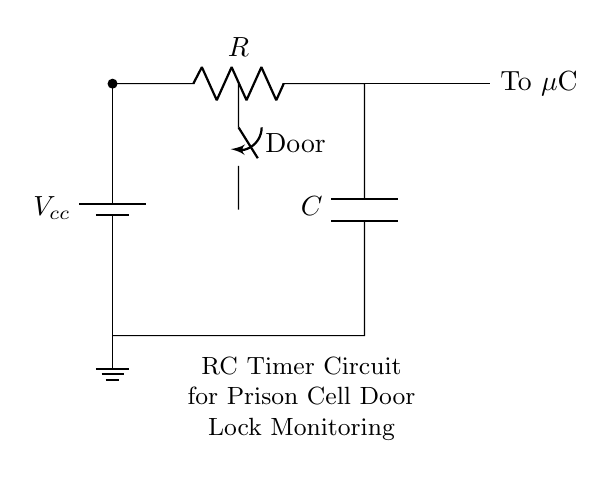What type of circuit is shown? The circuit is an RC timer circuit, which combines a resistor and capacitor to create a timing mechanism. This type of circuit is commonly used for timing applications and monitoring tasks such as door lock status.
Answer: RC timer circuit What is the function of the switch in this circuit? The switch represents the door status; when the door is closed, the switch is in one state (open or closed depending on the design choice), allowing the timing circuit to monitor the door lock status, influencing the output to the microcontroller.
Answer: Door status What components are present in the circuit? The primary components are a resistor, a capacitor, a battery (power supply), a switch, and a connection to a microcontroller. These components work together to monitor the door lock status.
Answer: Resistor, capacitor, battery, switch, microcontroller What does the output of this circuit connect to? The output connects to a microcontroller, which is responsible for processing the information from the timer circuit and potentially initiating actions based on the door status.
Answer: Microcontroller What is the role of the resistor in the RC circuit? The resistor controls the charging and discharging rate of the capacitor, which directly influences the timing behavior of the circuit. The resistance value, in conjunction with the capacitance, determines the time constant for the circuit and, therefore, how quickly it responds to changes in the door status.
Answer: Controls timing How does the capacitor affect the circuit's timing? The capacitor stores electrical energy and releases it gradually, which means it affects how long the output signal at the microcontroller remains active after the switch state changes, thus influencing the overall timing behavior of the circuit. The time constant is calculated by multiplying the resistance and capacitance values.
Answer: Affects timing duration 